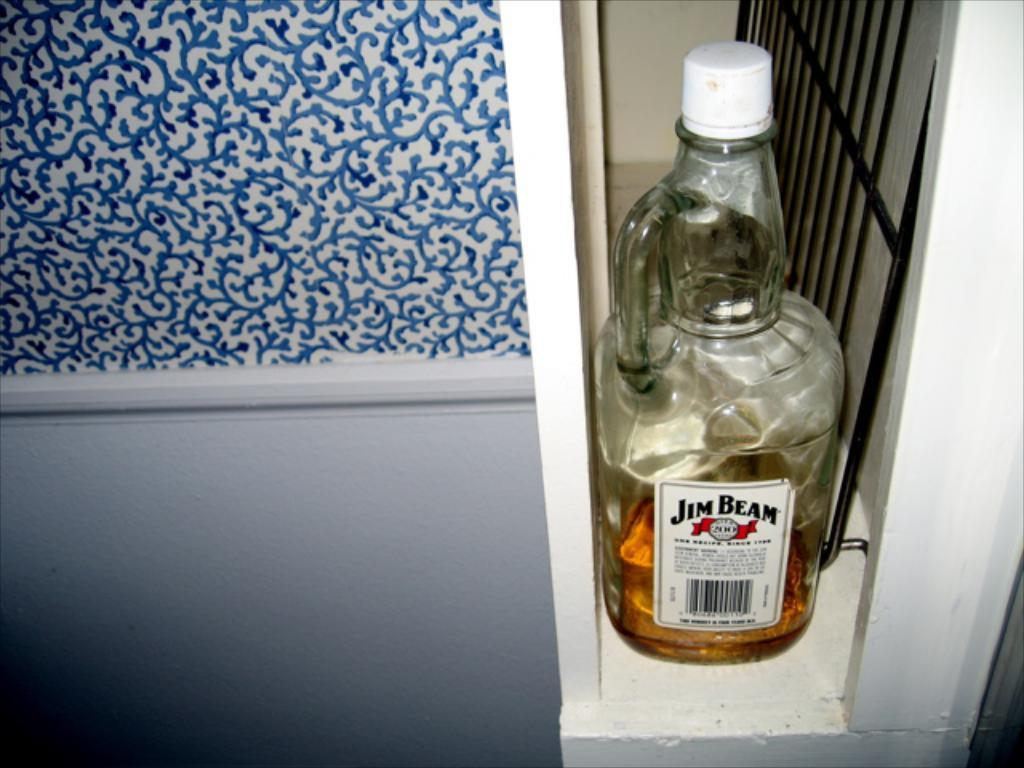<image>
Provide a brief description of the given image. A bottle of Jim Beam whiskey next to a blue and white picture. 